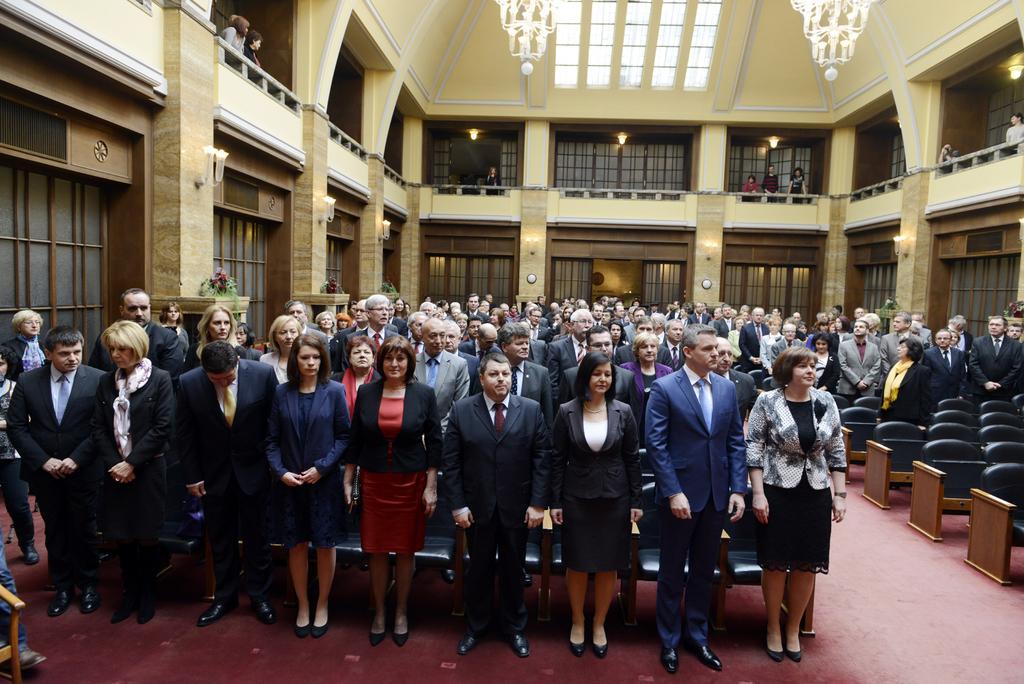Can you describe this image briefly? In this image, we can see an inside view of a building. There are people in the middle of the image wearing clothes. There are seats on the right side of the image. There are chandeliers at the top of the image. 